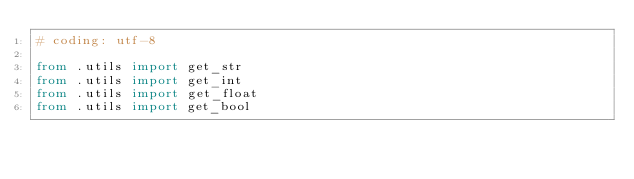Convert code to text. <code><loc_0><loc_0><loc_500><loc_500><_Python_># coding: utf-8

from .utils import get_str
from .utils import get_int
from .utils import get_float
from .utils import get_bool</code> 